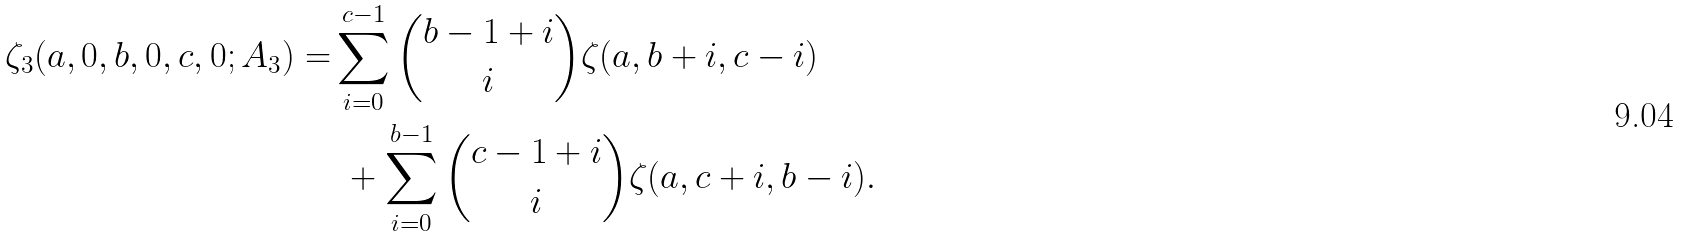Convert formula to latex. <formula><loc_0><loc_0><loc_500><loc_500>\zeta _ { 3 } ( a , 0 , b , 0 , c , 0 ; A _ { 3 } ) = & \sum _ { i = 0 } ^ { c - 1 } \binom { b - 1 + i } { i } \zeta ( a , b + i , c - i ) \\ & \ + \sum _ { i = 0 } ^ { b - 1 } \binom { c - 1 + i } { i } \zeta ( a , c + i , b - i ) .</formula> 